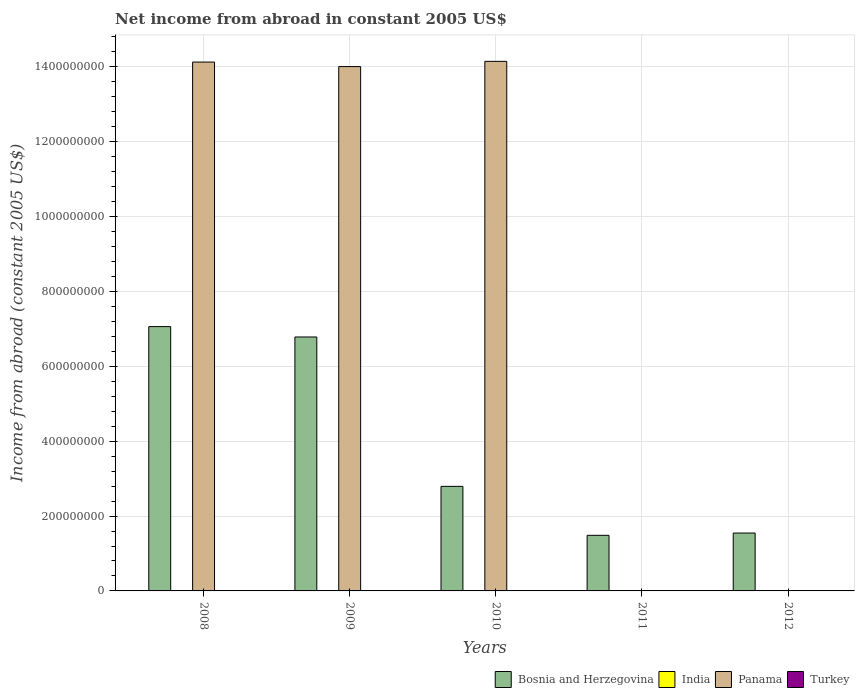Are the number of bars on each tick of the X-axis equal?
Offer a very short reply. No. How many bars are there on the 5th tick from the left?
Ensure brevity in your answer.  1. Across all years, what is the maximum net income from abroad in Panama?
Offer a very short reply. 1.41e+09. In which year was the net income from abroad in Bosnia and Herzegovina maximum?
Offer a very short reply. 2008. What is the total net income from abroad in Bosnia and Herzegovina in the graph?
Provide a short and direct response. 1.97e+09. What is the difference between the net income from abroad in Bosnia and Herzegovina in 2009 and that in 2011?
Ensure brevity in your answer.  5.30e+08. What is the difference between the net income from abroad in Turkey in 2010 and the net income from abroad in Bosnia and Herzegovina in 2009?
Offer a terse response. -6.78e+08. What is the average net income from abroad in Bosnia and Herzegovina per year?
Give a very brief answer. 3.93e+08. In the year 2010, what is the difference between the net income from abroad in Panama and net income from abroad in Bosnia and Herzegovina?
Offer a very short reply. 1.14e+09. What is the ratio of the net income from abroad in Panama in 2008 to that in 2009?
Provide a succinct answer. 1.01. Is the difference between the net income from abroad in Panama in 2008 and 2010 greater than the difference between the net income from abroad in Bosnia and Herzegovina in 2008 and 2010?
Give a very brief answer. No. What is the difference between the highest and the second highest net income from abroad in Bosnia and Herzegovina?
Your answer should be compact. 2.77e+07. What is the difference between the highest and the lowest net income from abroad in Bosnia and Herzegovina?
Offer a terse response. 5.58e+08. Is it the case that in every year, the sum of the net income from abroad in Bosnia and Herzegovina and net income from abroad in Turkey is greater than the sum of net income from abroad in Panama and net income from abroad in India?
Offer a very short reply. No. Is it the case that in every year, the sum of the net income from abroad in Panama and net income from abroad in India is greater than the net income from abroad in Bosnia and Herzegovina?
Give a very brief answer. No. Are all the bars in the graph horizontal?
Offer a terse response. No. What is the difference between two consecutive major ticks on the Y-axis?
Provide a succinct answer. 2.00e+08. Does the graph contain any zero values?
Make the answer very short. Yes. How many legend labels are there?
Provide a short and direct response. 4. What is the title of the graph?
Give a very brief answer. Net income from abroad in constant 2005 US$. What is the label or title of the X-axis?
Provide a succinct answer. Years. What is the label or title of the Y-axis?
Ensure brevity in your answer.  Income from abroad (constant 2005 US$). What is the Income from abroad (constant 2005 US$) of Bosnia and Herzegovina in 2008?
Your answer should be compact. 7.06e+08. What is the Income from abroad (constant 2005 US$) in Panama in 2008?
Offer a terse response. 1.41e+09. What is the Income from abroad (constant 2005 US$) in Bosnia and Herzegovina in 2009?
Your response must be concise. 6.78e+08. What is the Income from abroad (constant 2005 US$) in Panama in 2009?
Make the answer very short. 1.40e+09. What is the Income from abroad (constant 2005 US$) of Bosnia and Herzegovina in 2010?
Provide a succinct answer. 2.79e+08. What is the Income from abroad (constant 2005 US$) in India in 2010?
Your response must be concise. 0. What is the Income from abroad (constant 2005 US$) of Panama in 2010?
Offer a very short reply. 1.41e+09. What is the Income from abroad (constant 2005 US$) in Turkey in 2010?
Your response must be concise. 0. What is the Income from abroad (constant 2005 US$) in Bosnia and Herzegovina in 2011?
Make the answer very short. 1.49e+08. What is the Income from abroad (constant 2005 US$) in India in 2011?
Give a very brief answer. 0. What is the Income from abroad (constant 2005 US$) in Turkey in 2011?
Provide a succinct answer. 0. What is the Income from abroad (constant 2005 US$) in Bosnia and Herzegovina in 2012?
Keep it short and to the point. 1.55e+08. What is the Income from abroad (constant 2005 US$) of India in 2012?
Your answer should be compact. 0. What is the Income from abroad (constant 2005 US$) in Turkey in 2012?
Keep it short and to the point. 0. Across all years, what is the maximum Income from abroad (constant 2005 US$) in Bosnia and Herzegovina?
Keep it short and to the point. 7.06e+08. Across all years, what is the maximum Income from abroad (constant 2005 US$) of Panama?
Offer a terse response. 1.41e+09. Across all years, what is the minimum Income from abroad (constant 2005 US$) in Bosnia and Herzegovina?
Your answer should be very brief. 1.49e+08. Across all years, what is the minimum Income from abroad (constant 2005 US$) of Panama?
Provide a short and direct response. 0. What is the total Income from abroad (constant 2005 US$) in Bosnia and Herzegovina in the graph?
Your response must be concise. 1.97e+09. What is the total Income from abroad (constant 2005 US$) in India in the graph?
Ensure brevity in your answer.  0. What is the total Income from abroad (constant 2005 US$) in Panama in the graph?
Keep it short and to the point. 4.23e+09. What is the difference between the Income from abroad (constant 2005 US$) in Bosnia and Herzegovina in 2008 and that in 2009?
Your answer should be compact. 2.77e+07. What is the difference between the Income from abroad (constant 2005 US$) in Panama in 2008 and that in 2009?
Offer a very short reply. 1.21e+07. What is the difference between the Income from abroad (constant 2005 US$) of Bosnia and Herzegovina in 2008 and that in 2010?
Offer a terse response. 4.27e+08. What is the difference between the Income from abroad (constant 2005 US$) of Panama in 2008 and that in 2010?
Your answer should be compact. -1.90e+06. What is the difference between the Income from abroad (constant 2005 US$) of Bosnia and Herzegovina in 2008 and that in 2011?
Keep it short and to the point. 5.58e+08. What is the difference between the Income from abroad (constant 2005 US$) of Bosnia and Herzegovina in 2008 and that in 2012?
Give a very brief answer. 5.52e+08. What is the difference between the Income from abroad (constant 2005 US$) in Bosnia and Herzegovina in 2009 and that in 2010?
Offer a terse response. 3.99e+08. What is the difference between the Income from abroad (constant 2005 US$) of Panama in 2009 and that in 2010?
Provide a short and direct response. -1.40e+07. What is the difference between the Income from abroad (constant 2005 US$) in Bosnia and Herzegovina in 2009 and that in 2011?
Your answer should be very brief. 5.30e+08. What is the difference between the Income from abroad (constant 2005 US$) in Bosnia and Herzegovina in 2009 and that in 2012?
Your answer should be very brief. 5.24e+08. What is the difference between the Income from abroad (constant 2005 US$) of Bosnia and Herzegovina in 2010 and that in 2011?
Offer a very short reply. 1.31e+08. What is the difference between the Income from abroad (constant 2005 US$) in Bosnia and Herzegovina in 2010 and that in 2012?
Provide a short and direct response. 1.25e+08. What is the difference between the Income from abroad (constant 2005 US$) of Bosnia and Herzegovina in 2011 and that in 2012?
Your response must be concise. -6.13e+06. What is the difference between the Income from abroad (constant 2005 US$) of Bosnia and Herzegovina in 2008 and the Income from abroad (constant 2005 US$) of Panama in 2009?
Provide a short and direct response. -6.95e+08. What is the difference between the Income from abroad (constant 2005 US$) in Bosnia and Herzegovina in 2008 and the Income from abroad (constant 2005 US$) in Panama in 2010?
Keep it short and to the point. -7.09e+08. What is the difference between the Income from abroad (constant 2005 US$) in Bosnia and Herzegovina in 2009 and the Income from abroad (constant 2005 US$) in Panama in 2010?
Ensure brevity in your answer.  -7.36e+08. What is the average Income from abroad (constant 2005 US$) in Bosnia and Herzegovina per year?
Provide a succinct answer. 3.93e+08. What is the average Income from abroad (constant 2005 US$) of Panama per year?
Provide a succinct answer. 8.46e+08. In the year 2008, what is the difference between the Income from abroad (constant 2005 US$) in Bosnia and Herzegovina and Income from abroad (constant 2005 US$) in Panama?
Your answer should be very brief. -7.07e+08. In the year 2009, what is the difference between the Income from abroad (constant 2005 US$) in Bosnia and Herzegovina and Income from abroad (constant 2005 US$) in Panama?
Your response must be concise. -7.22e+08. In the year 2010, what is the difference between the Income from abroad (constant 2005 US$) of Bosnia and Herzegovina and Income from abroad (constant 2005 US$) of Panama?
Give a very brief answer. -1.14e+09. What is the ratio of the Income from abroad (constant 2005 US$) of Bosnia and Herzegovina in 2008 to that in 2009?
Your response must be concise. 1.04. What is the ratio of the Income from abroad (constant 2005 US$) in Panama in 2008 to that in 2009?
Ensure brevity in your answer.  1.01. What is the ratio of the Income from abroad (constant 2005 US$) in Bosnia and Herzegovina in 2008 to that in 2010?
Offer a terse response. 2.53. What is the ratio of the Income from abroad (constant 2005 US$) of Panama in 2008 to that in 2010?
Keep it short and to the point. 1. What is the ratio of the Income from abroad (constant 2005 US$) in Bosnia and Herzegovina in 2008 to that in 2011?
Make the answer very short. 4.75. What is the ratio of the Income from abroad (constant 2005 US$) of Bosnia and Herzegovina in 2008 to that in 2012?
Keep it short and to the point. 4.57. What is the ratio of the Income from abroad (constant 2005 US$) in Bosnia and Herzegovina in 2009 to that in 2010?
Give a very brief answer. 2.43. What is the ratio of the Income from abroad (constant 2005 US$) of Panama in 2009 to that in 2010?
Provide a succinct answer. 0.99. What is the ratio of the Income from abroad (constant 2005 US$) of Bosnia and Herzegovina in 2009 to that in 2011?
Give a very brief answer. 4.57. What is the ratio of the Income from abroad (constant 2005 US$) in Bosnia and Herzegovina in 2009 to that in 2012?
Make the answer very short. 4.39. What is the ratio of the Income from abroad (constant 2005 US$) of Bosnia and Herzegovina in 2010 to that in 2011?
Offer a very short reply. 1.88. What is the ratio of the Income from abroad (constant 2005 US$) of Bosnia and Herzegovina in 2010 to that in 2012?
Provide a succinct answer. 1.81. What is the ratio of the Income from abroad (constant 2005 US$) in Bosnia and Herzegovina in 2011 to that in 2012?
Offer a terse response. 0.96. What is the difference between the highest and the second highest Income from abroad (constant 2005 US$) of Bosnia and Herzegovina?
Keep it short and to the point. 2.77e+07. What is the difference between the highest and the second highest Income from abroad (constant 2005 US$) of Panama?
Provide a succinct answer. 1.90e+06. What is the difference between the highest and the lowest Income from abroad (constant 2005 US$) of Bosnia and Herzegovina?
Ensure brevity in your answer.  5.58e+08. What is the difference between the highest and the lowest Income from abroad (constant 2005 US$) of Panama?
Give a very brief answer. 1.41e+09. 